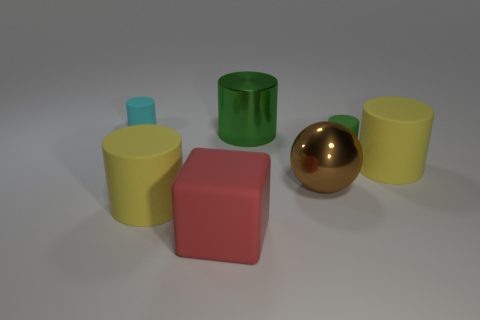What is the shape of the tiny rubber thing in front of the small rubber cylinder that is on the left side of the big block?
Your answer should be very brief. Cylinder. Are the big green thing and the green object to the right of the large green metallic object made of the same material?
Your answer should be compact. No. The tiny matte object that is the same color as the metallic cylinder is what shape?
Make the answer very short. Cylinder. What number of cyan objects have the same size as the green rubber cylinder?
Offer a terse response. 1. Are there fewer green objects that are to the left of the large red rubber object than big purple matte spheres?
Give a very brief answer. No. How many big yellow objects are in front of the cyan matte cylinder?
Provide a short and direct response. 2. There is a shiny thing in front of the small cylinder right of the tiny cylinder that is on the left side of the cube; what is its size?
Provide a short and direct response. Large. There is a cyan rubber object; does it have the same shape as the metallic thing that is in front of the large metallic cylinder?
Keep it short and to the point. No. What size is the cylinder that is made of the same material as the brown sphere?
Offer a very short reply. Large. Are there any other things of the same color as the shiny cylinder?
Make the answer very short. Yes. 